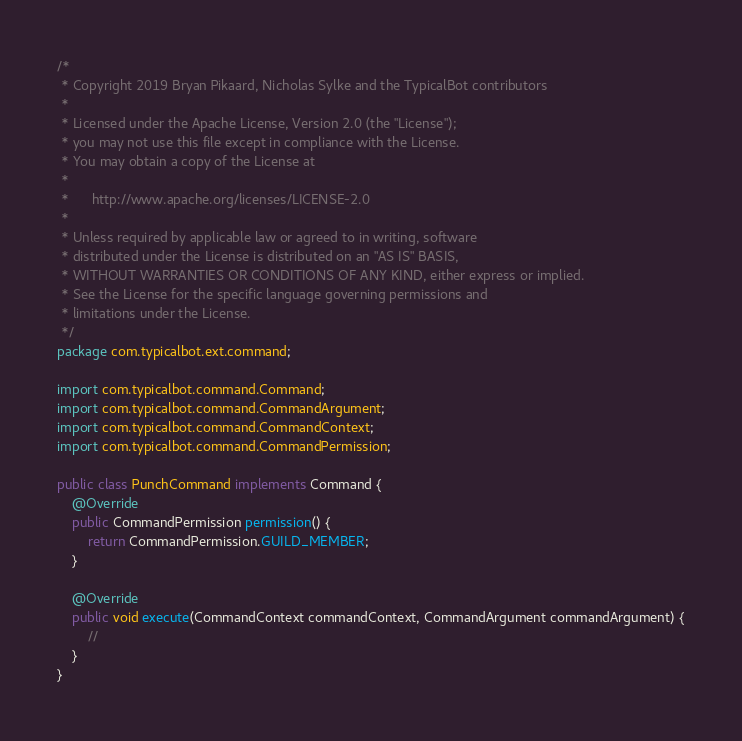Convert code to text. <code><loc_0><loc_0><loc_500><loc_500><_Java_>/*
 * Copyright 2019 Bryan Pikaard, Nicholas Sylke and the TypicalBot contributors
 *
 * Licensed under the Apache License, Version 2.0 (the "License");
 * you may not use this file except in compliance with the License.
 * You may obtain a copy of the License at
 *
 *      http://www.apache.org/licenses/LICENSE-2.0
 *
 * Unless required by applicable law or agreed to in writing, software
 * distributed under the License is distributed on an "AS IS" BASIS,
 * WITHOUT WARRANTIES OR CONDITIONS OF ANY KIND, either express or implied.
 * See the License for the specific language governing permissions and
 * limitations under the License.
 */
package com.typicalbot.ext.command;

import com.typicalbot.command.Command;
import com.typicalbot.command.CommandArgument;
import com.typicalbot.command.CommandContext;
import com.typicalbot.command.CommandPermission;

public class PunchCommand implements Command {
    @Override
    public CommandPermission permission() {
        return CommandPermission.GUILD_MEMBER;
    }

    @Override
    public void execute(CommandContext commandContext, CommandArgument commandArgument) {
        //
    }
}
</code> 